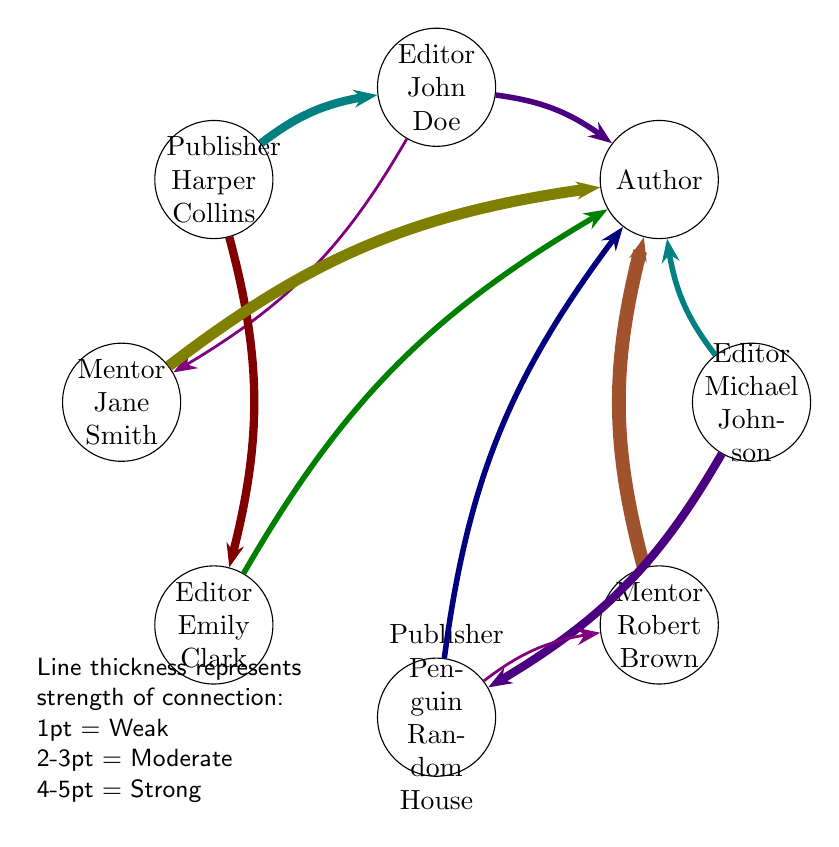What is the total number of nodes in the diagram? The diagram depicts 8 nodes. They are: Author, Editor John Doe, Publisher HarperCollins, Mentor Jane Smith, Editor Emily Clark, Publisher Penguin Random House, Mentor Robert Brown, and Editor Michael Johnson. Counting these gives us a total of 8 nodes.
Answer: 8 Which editor has the strongest connection to the author? Looking at the connections to the Author, Mentor Robert Brown has the strongest connection (5), followed by Mentor Jane Smith (4). However, the strong connections directly from editors to the Author are as follows: Editor John Doe and Editor Emily Clark both have a connection value of 2. Therefore, Mentor Robert Brown has the overall highest connection to the Author despite not being an editor.
Answer: Mentor Robert Brown How many connections does PublisherPenguin Random House have? The connections for Publisher Penguin Random House are as follows: it connects to the Author (2), Editor Michael Johnson (3), and Mentor Robert Brown (1). Summing those gives us a total of 3 connections.
Answer: 3 What is the value of the connection from Editor Michael Johnson to Publisher Penguin Random House? By examining the links, we find that Editor Michael Johnson has a connection to Publisher Penguin Random House with the value of 3. This indicates a moderate strength in the relationship between them.
Answer: 3 Which mentor has the weakest connection to the author? Analyzing the connections to the Author, Mentor Jane Smith has a connection value of 4, and Mentor Robert Brown has a connection value of 5. Since both mentors have connections, the weaker of the two is Mentor Jane Smith.
Answer: Mentor Jane Smith What type of relationship does Editor John Doe have with Mentor Jane Smith? The link between Editor John Doe and Mentor Jane Smith has a connection value of 1, indicating a weak relationship. This shows that while there is some connection between them, it is not strong.
Answer: Weak Which node has connections to both publishers? Checking each node, only the Author has connections to both Publisher HarperCollins (2) and Publisher Penguin Random House (2). Therefore, the Author is the node connected to both publishers.
Answer: Author How many connections does the Mentor Robert Brown have to the Author? Reviewing the diagram, Mentor Robert Brown has a connection to the Author with a value of 5, indicating a strong influence or guidance in this relationship.
Answer: 5 What is the nature of the relationship between Editor Michael Johnson and Author? The link shows that Editor Michael Johnson has a connection to the Author with a value of 2. This indicates a moderate strength in their relationship, signifying that there is some active involvement or influence.
Answer: Moderate 